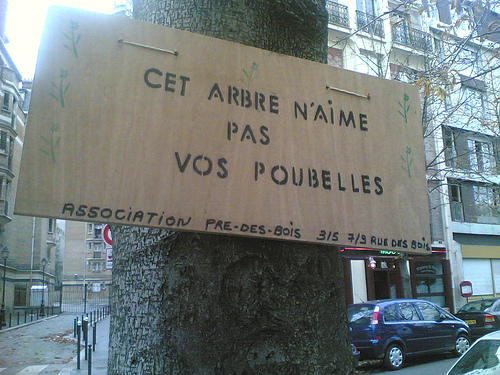Identify and read out the text in this image. CET ARBRE NAIME PAS VOS DES RUE 7/9 315 PRE-DES-BOIS ASSOCIATION POUBELLES 